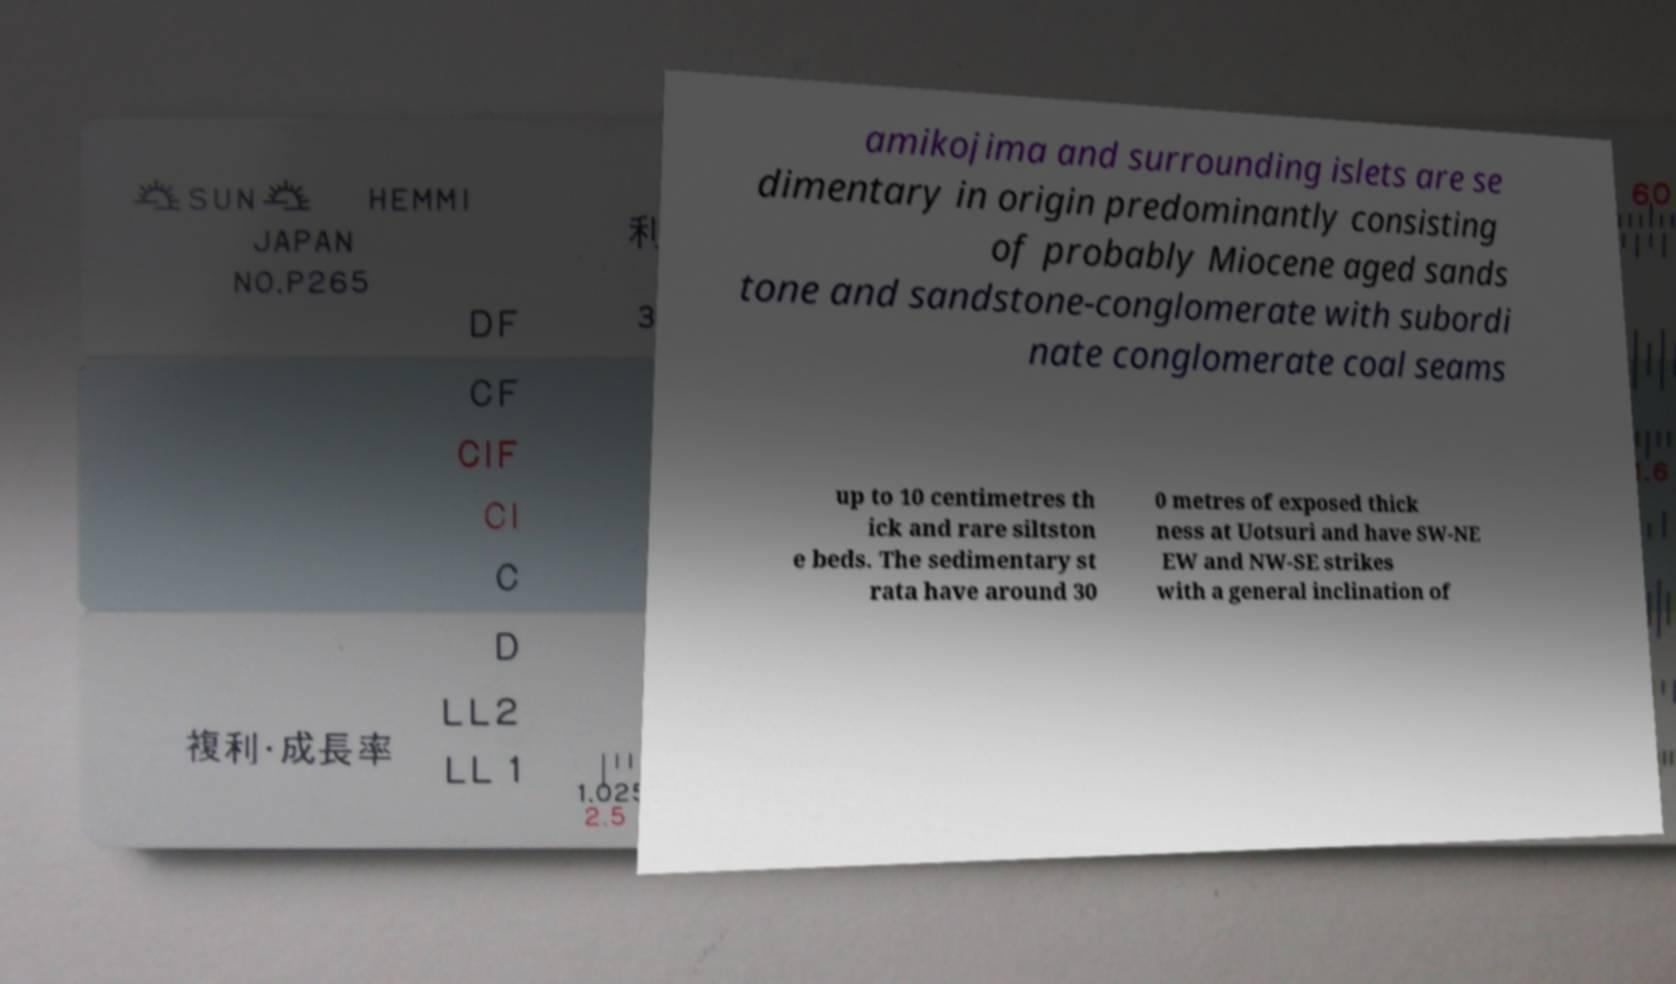Can you accurately transcribe the text from the provided image for me? amikojima and surrounding islets are se dimentary in origin predominantly consisting of probably Miocene aged sands tone and sandstone-conglomerate with subordi nate conglomerate coal seams up to 10 centimetres th ick and rare siltston e beds. The sedimentary st rata have around 30 0 metres of exposed thick ness at Uotsuri and have SW-NE EW and NW-SE strikes with a general inclination of 